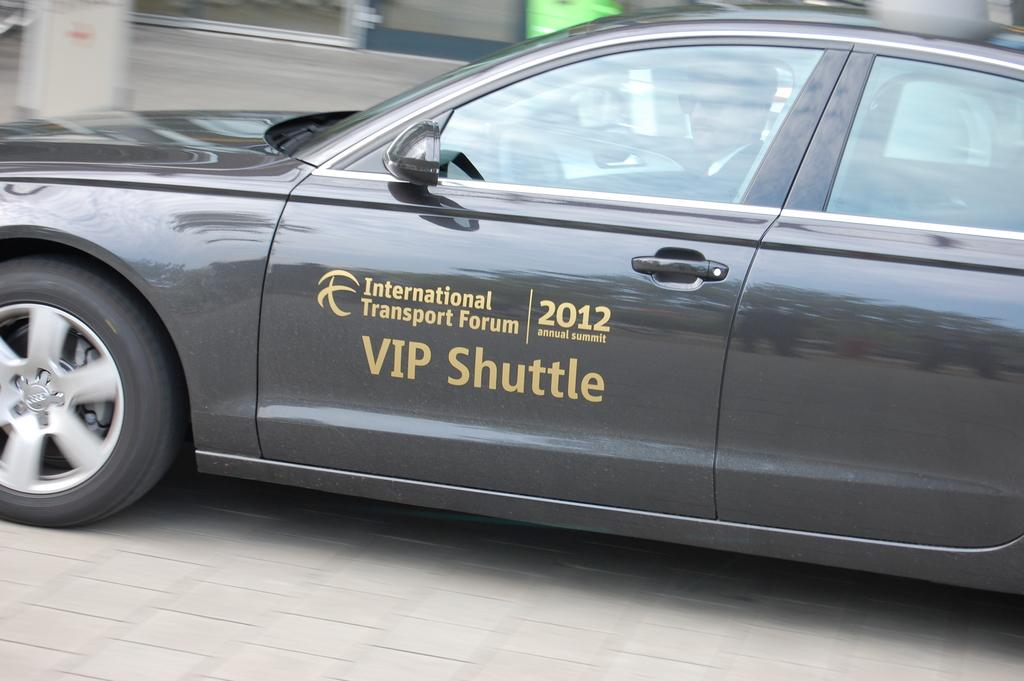What is the color of the vehicle in the image? The vehicle in the image is gray. Are there any other notable features on the vehicle? Yes, there are golden color texts on the vehicle. Where is the vehicle located in the image? The vehicle is on the road. Can you describe the background of the image? The background of the image is blurred. What is the tendency of the silver object in the image? There is no silver object present in the image. What type of punishment is being given to the person in the vehicle in the image? There is no indication of any punishment being given to the person in the vehicle in the image. 